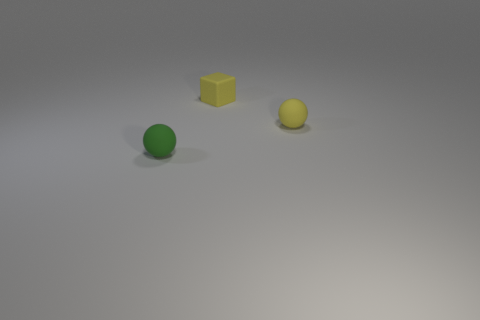How many matte spheres are there?
Make the answer very short. 2. There is a small thing that is behind the small matte ball that is behind the green ball; what is it made of?
Provide a succinct answer. Rubber. There is a yellow rubber thing on the left side of the yellow matte ball; is its shape the same as the tiny green thing?
Your answer should be very brief. No. What number of things are large blue objects or tiny matte objects that are behind the small green matte thing?
Provide a succinct answer. 2. Are there fewer tiny yellow blocks than green rubber blocks?
Your response must be concise. No. Are there more matte blocks than cyan things?
Provide a short and direct response. Yes. What number of other things are made of the same material as the tiny green object?
Your answer should be very brief. 2. What number of small yellow blocks are in front of the object in front of the small object right of the tiny yellow cube?
Your answer should be very brief. 0. How many rubber objects are either green objects or small gray cubes?
Keep it short and to the point. 1. What size is the yellow rubber thing to the left of the small matte sphere that is to the right of the small rubber cube?
Offer a very short reply. Small. 